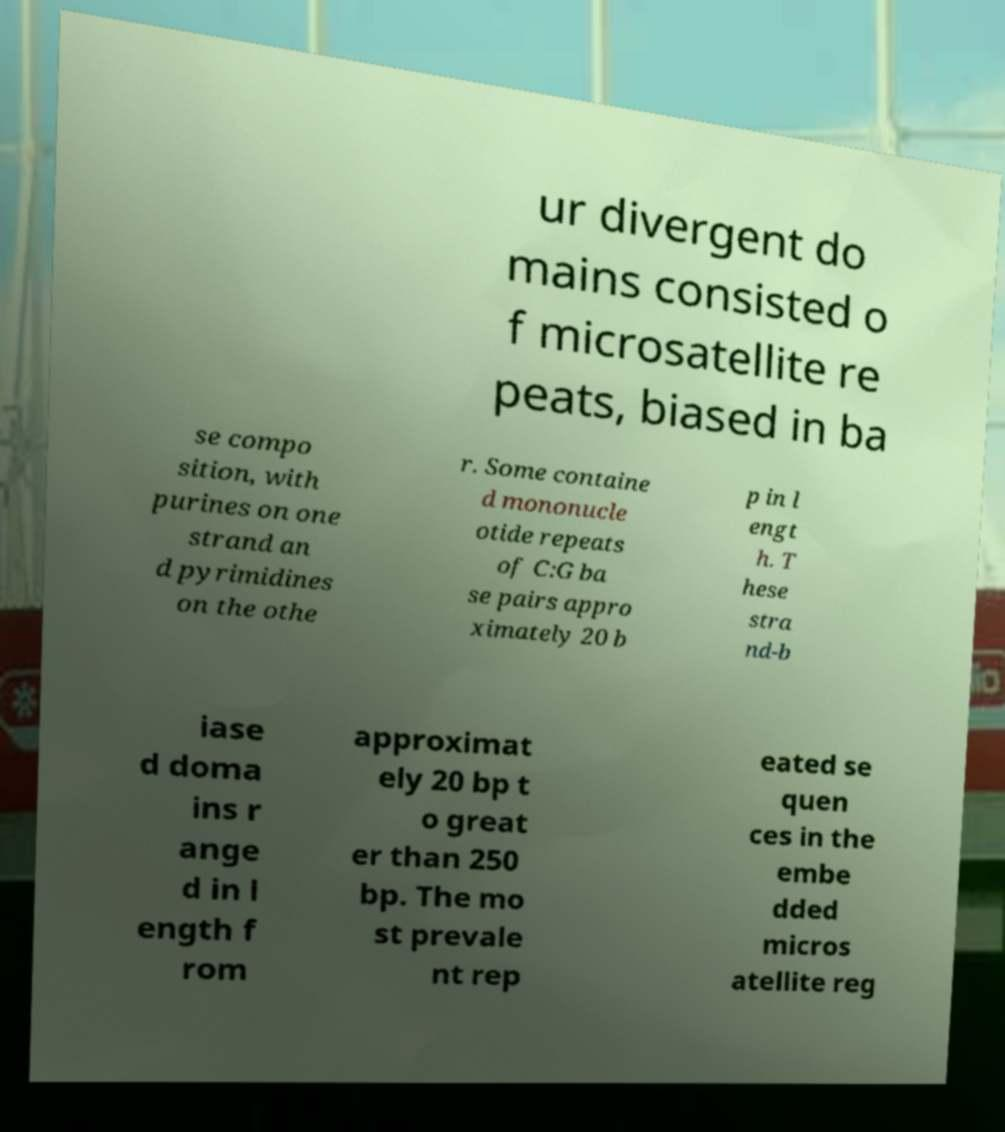Can you read and provide the text displayed in the image?This photo seems to have some interesting text. Can you extract and type it out for me? ur divergent do mains consisted o f microsatellite re peats, biased in ba se compo sition, with purines on one strand an d pyrimidines on the othe r. Some containe d mononucle otide repeats of C:G ba se pairs appro ximately 20 b p in l engt h. T hese stra nd-b iase d doma ins r ange d in l ength f rom approximat ely 20 bp t o great er than 250 bp. The mo st prevale nt rep eated se quen ces in the embe dded micros atellite reg 